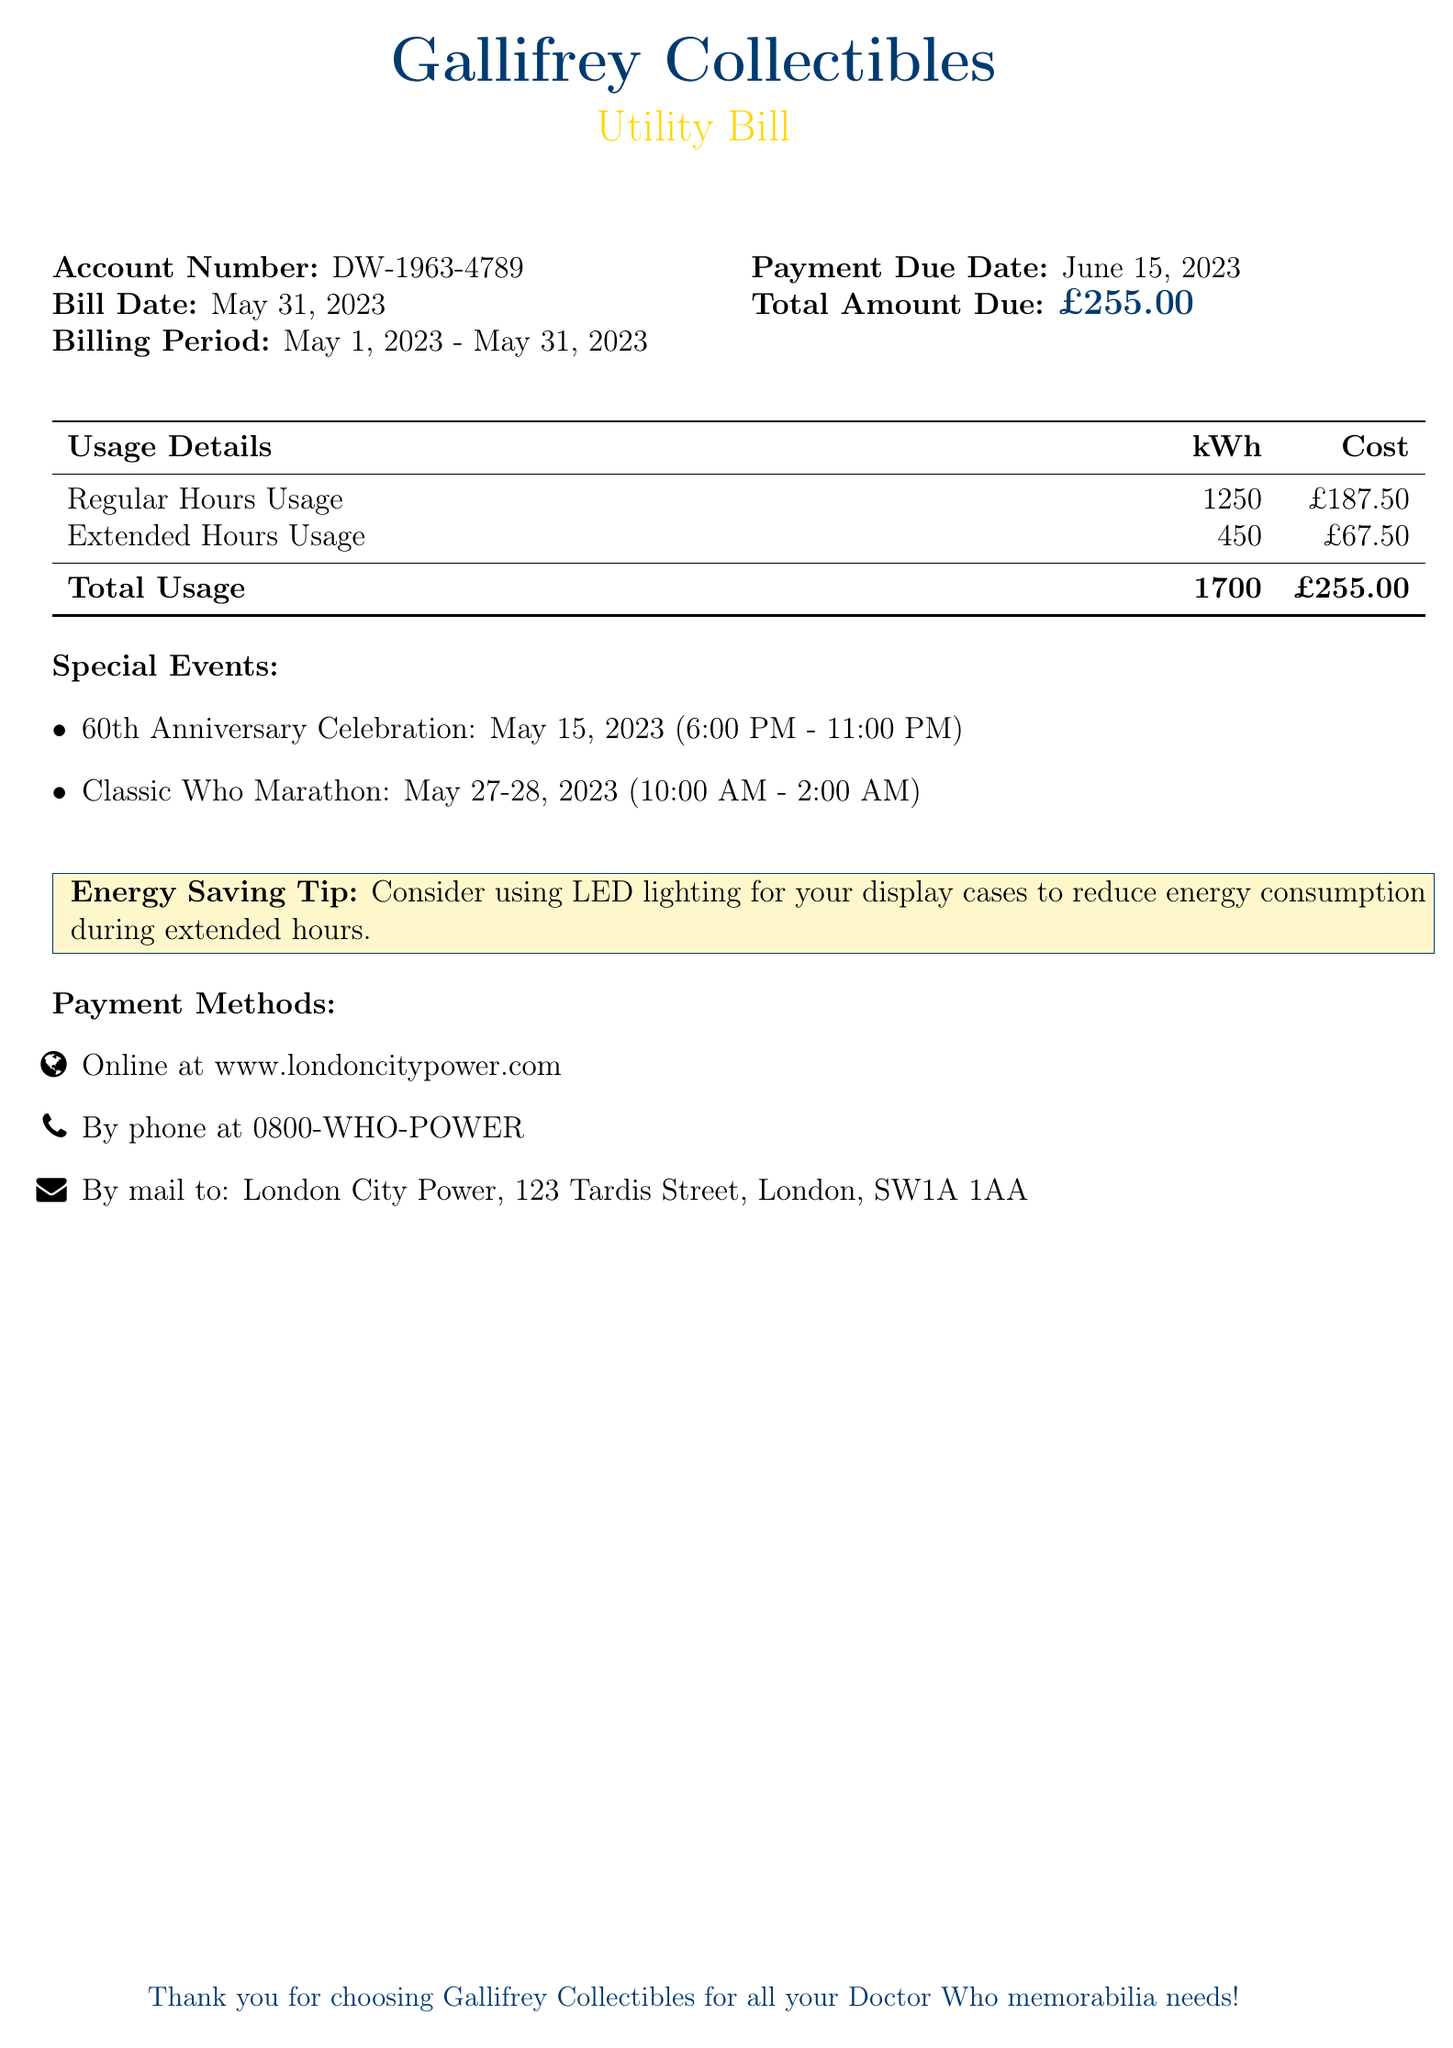What is the account number? The account number is specified in the document and is unique for each billing account.
Answer: DW-1963-4789 What is the billing period? The billing period indicates the time frame for which the utilities are billed, shown in the document.
Answer: May 1, 2023 - May 31, 2023 What is the total amount due? The total amount due is the final charge listed for the billing period, reflecting total costs.
Answer: £255.00 How much was used during extended hours? The document details the electricity usage for different segments, including extended hours.
Answer: 450 kWh What is one of the special events listed? The special events are mentioned in the document and involve notable gatherings that increased usage.
Answer: 60th Anniversary Celebration What is the cost for regular hours usage? The document lists the cost associated with regular hours, which contributes to the total amount due.
Answer: £187.50 What payment methods are available? The document includes various options for making payment, showing flexibility for customers.
Answer: Online at www.londoncitypower.com What is a suggested energy saving tip? The document provides helpful tips for reducing energy consumption, aimed at saving costs.
Answer: Consider using LED lighting for your display cases How many kilowatt-hours were used in total? The total energy usage combines both regular and extended hours, found in the usage table.
Answer: 1700 kWh When is the payment due date? The document specifies when the payment should be completed to avoid penalties.
Answer: June 15, 2023 